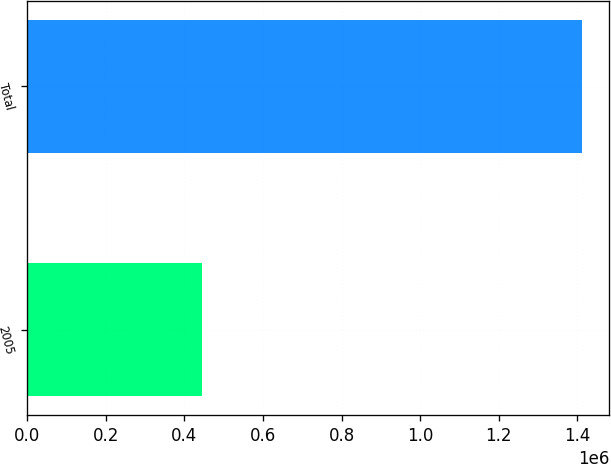Convert chart. <chart><loc_0><loc_0><loc_500><loc_500><bar_chart><fcel>2005<fcel>Total<nl><fcel>445014<fcel>1.41123e+06<nl></chart> 